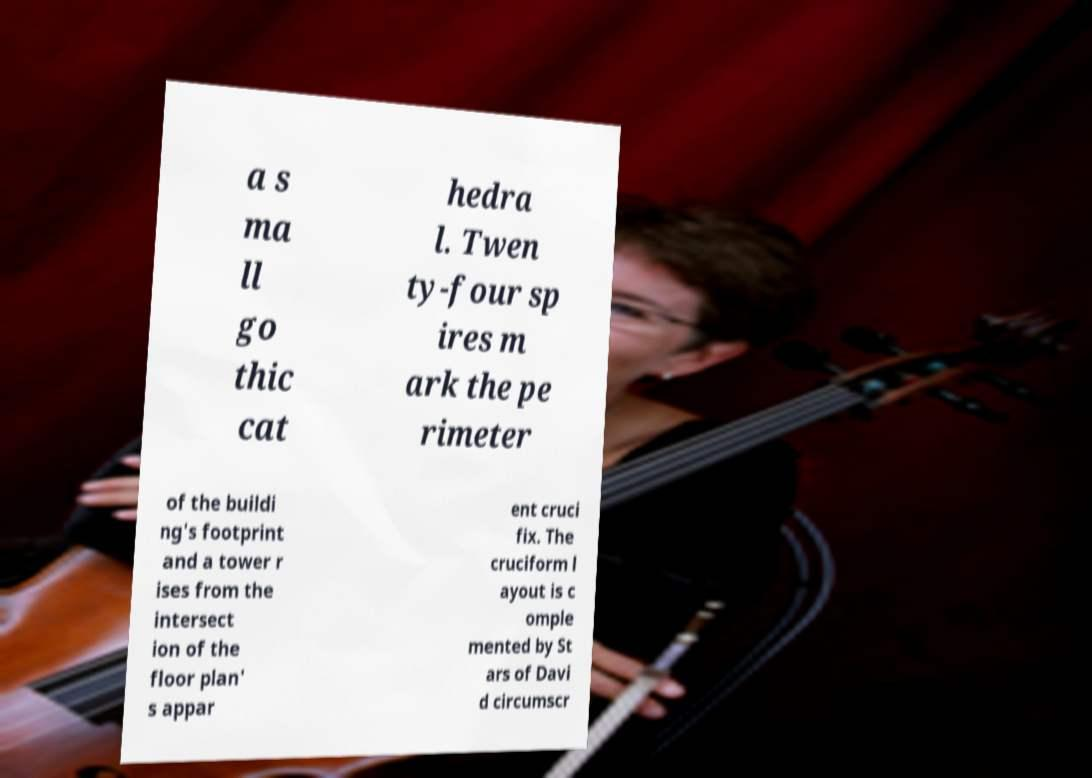Please read and relay the text visible in this image. What does it say? a s ma ll go thic cat hedra l. Twen ty-four sp ires m ark the pe rimeter of the buildi ng's footprint and a tower r ises from the intersect ion of the floor plan' s appar ent cruci fix. The cruciform l ayout is c omple mented by St ars of Davi d circumscr 